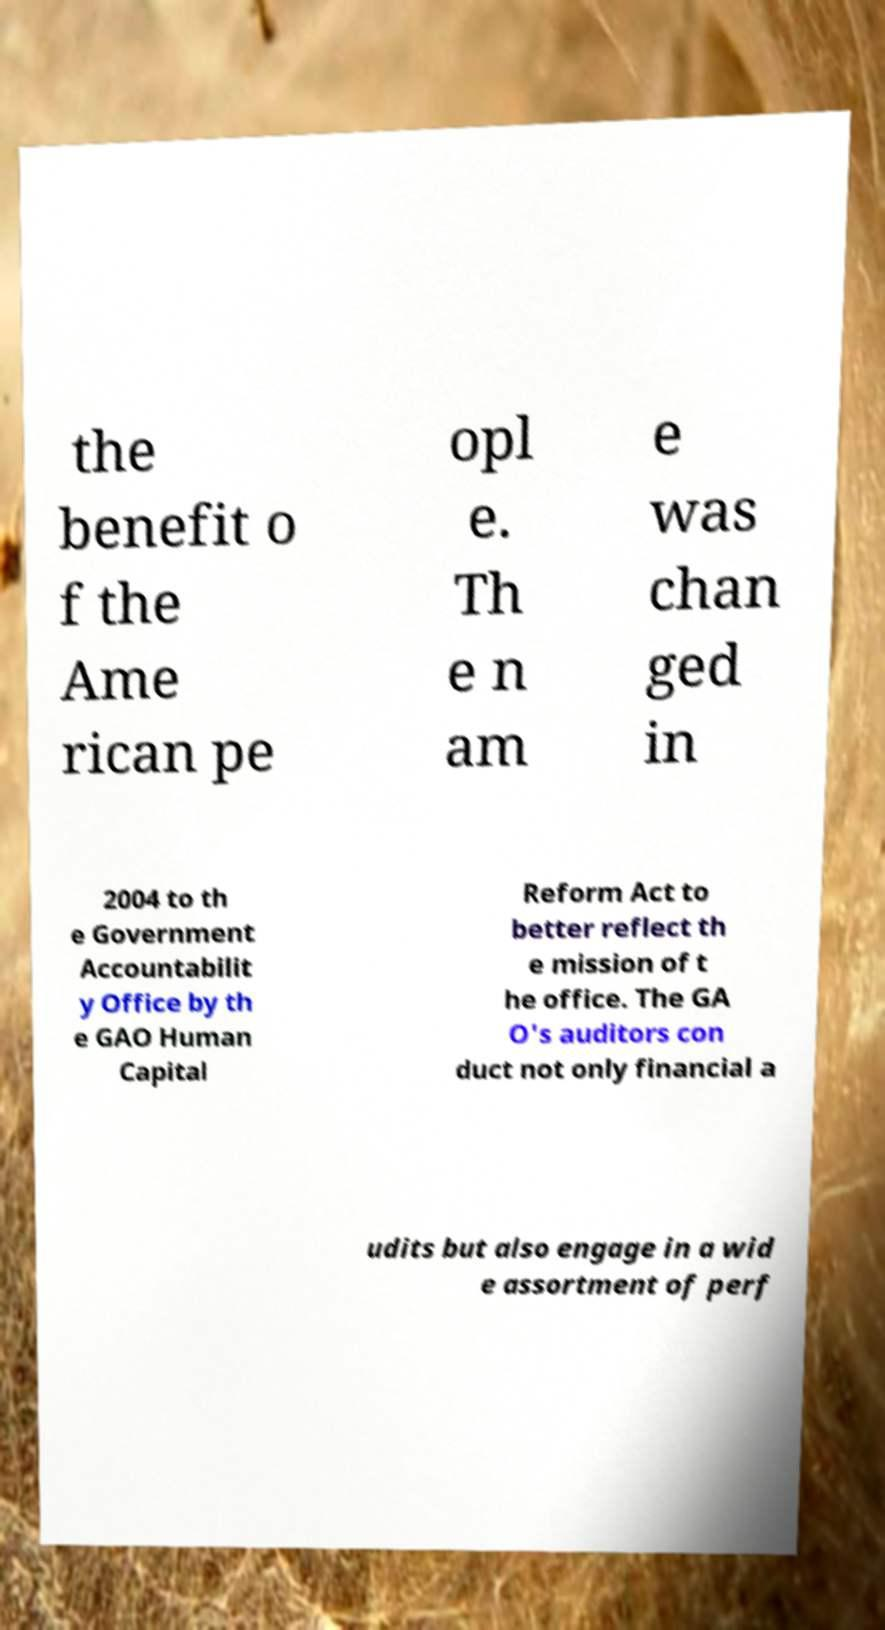What messages or text are displayed in this image? I need them in a readable, typed format. the benefit o f the Ame rican pe opl e. Th e n am e was chan ged in 2004 to th e Government Accountabilit y Office by th e GAO Human Capital Reform Act to better reflect th e mission of t he office. The GA O's auditors con duct not only financial a udits but also engage in a wid e assortment of perf 